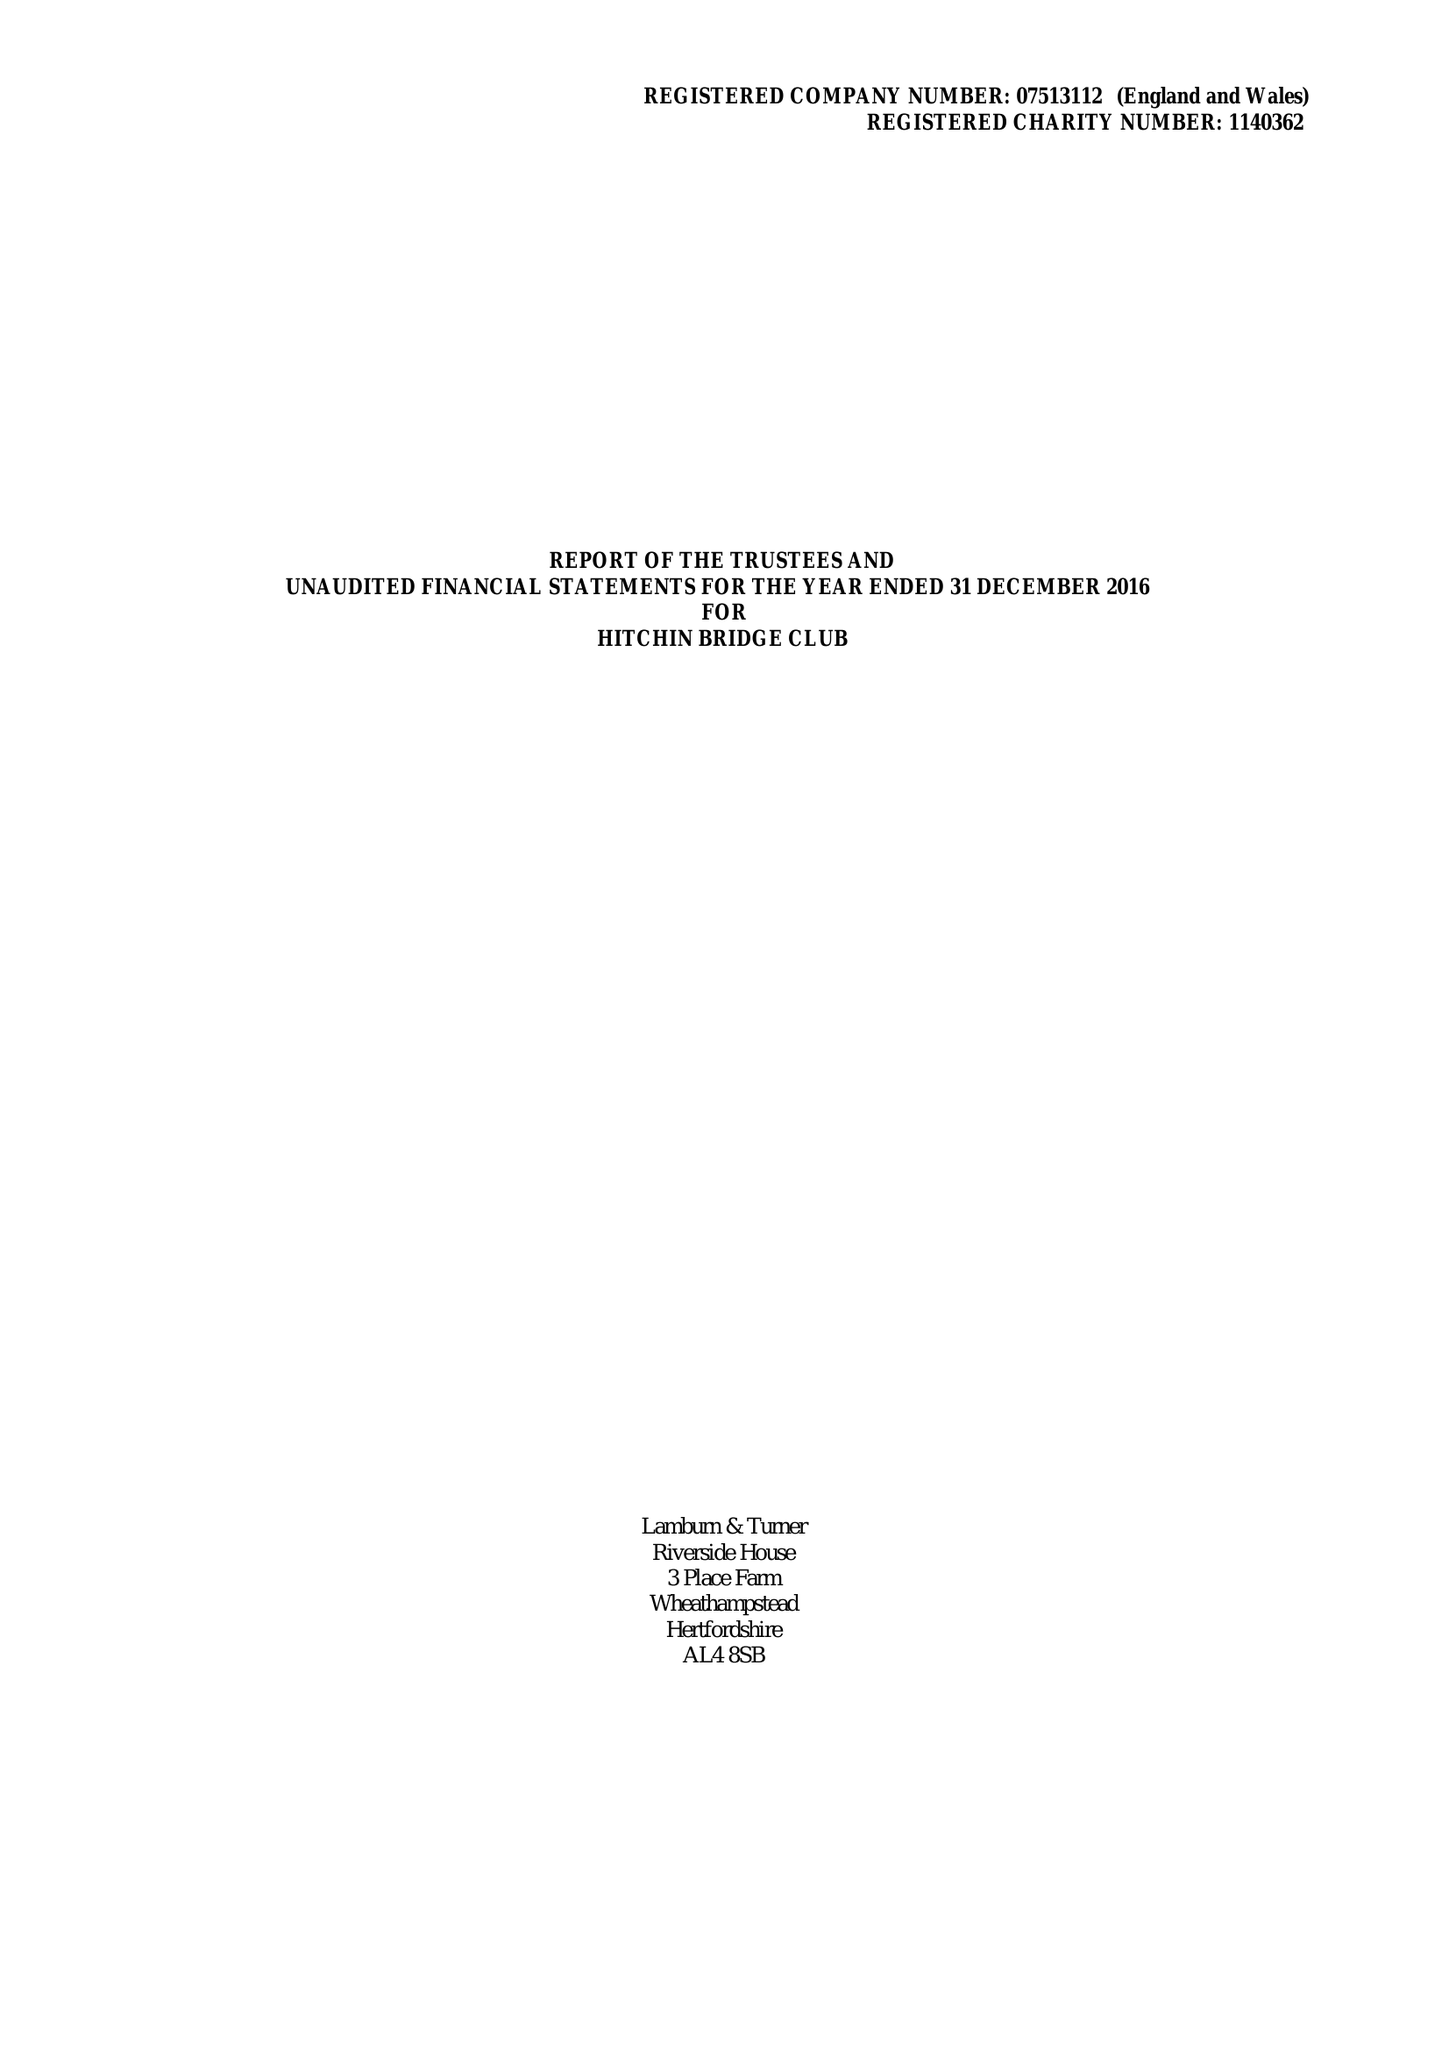What is the value for the charity_name?
Answer the question using a single word or phrase. Hitchin Bridge Club 